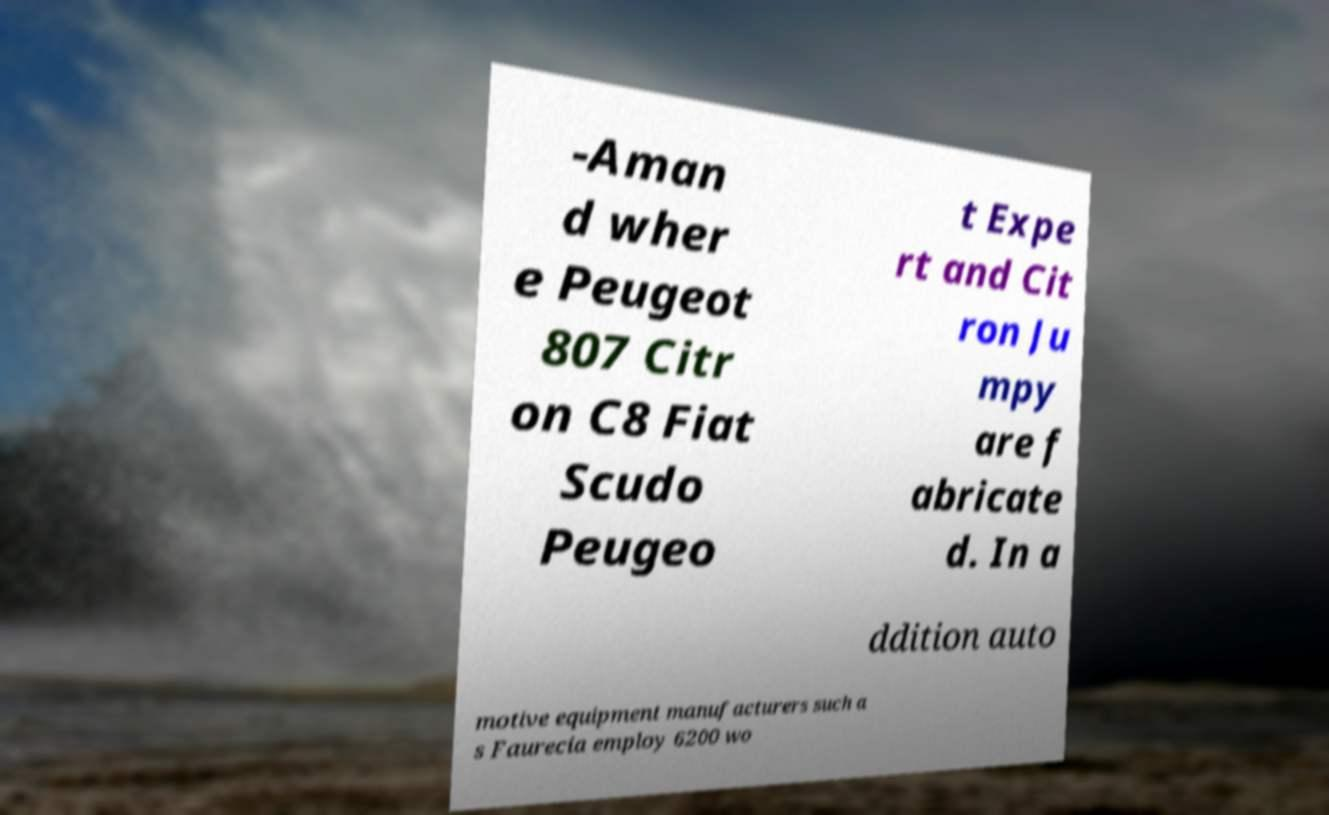What messages or text are displayed in this image? I need them in a readable, typed format. -Aman d wher e Peugeot 807 Citr on C8 Fiat Scudo Peugeo t Expe rt and Cit ron Ju mpy are f abricate d. In a ddition auto motive equipment manufacturers such a s Faurecia employ 6200 wo 